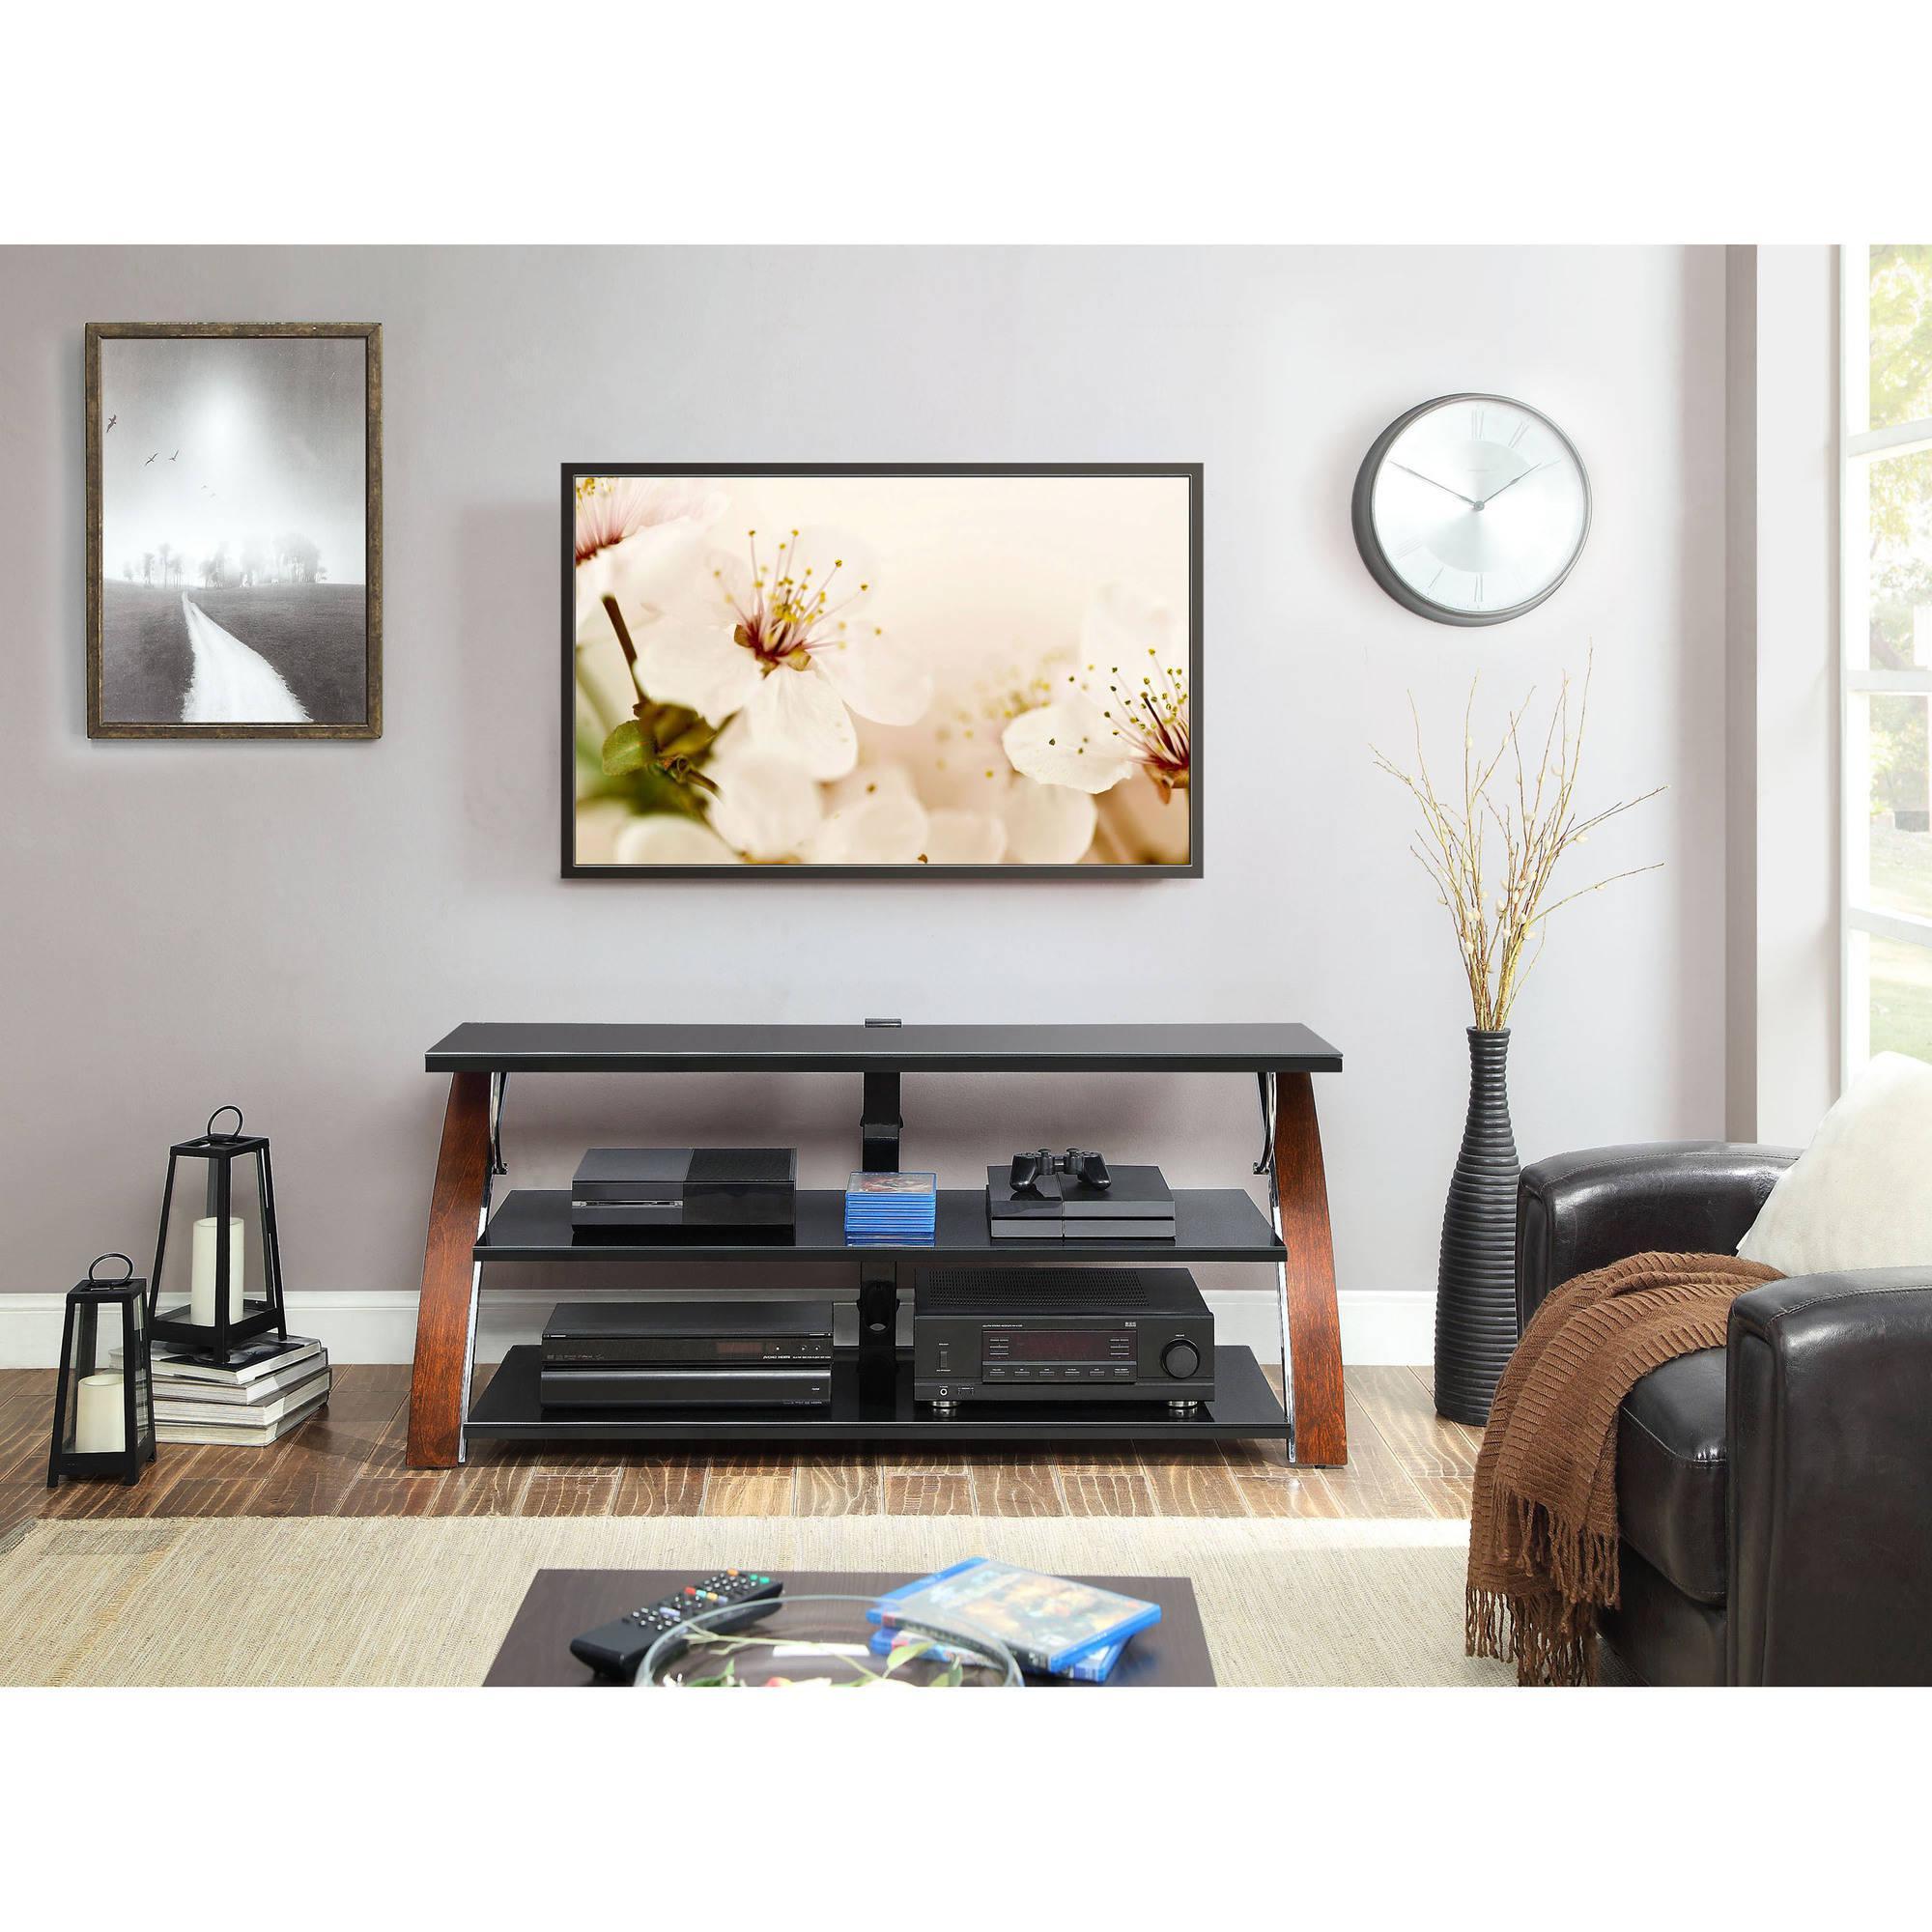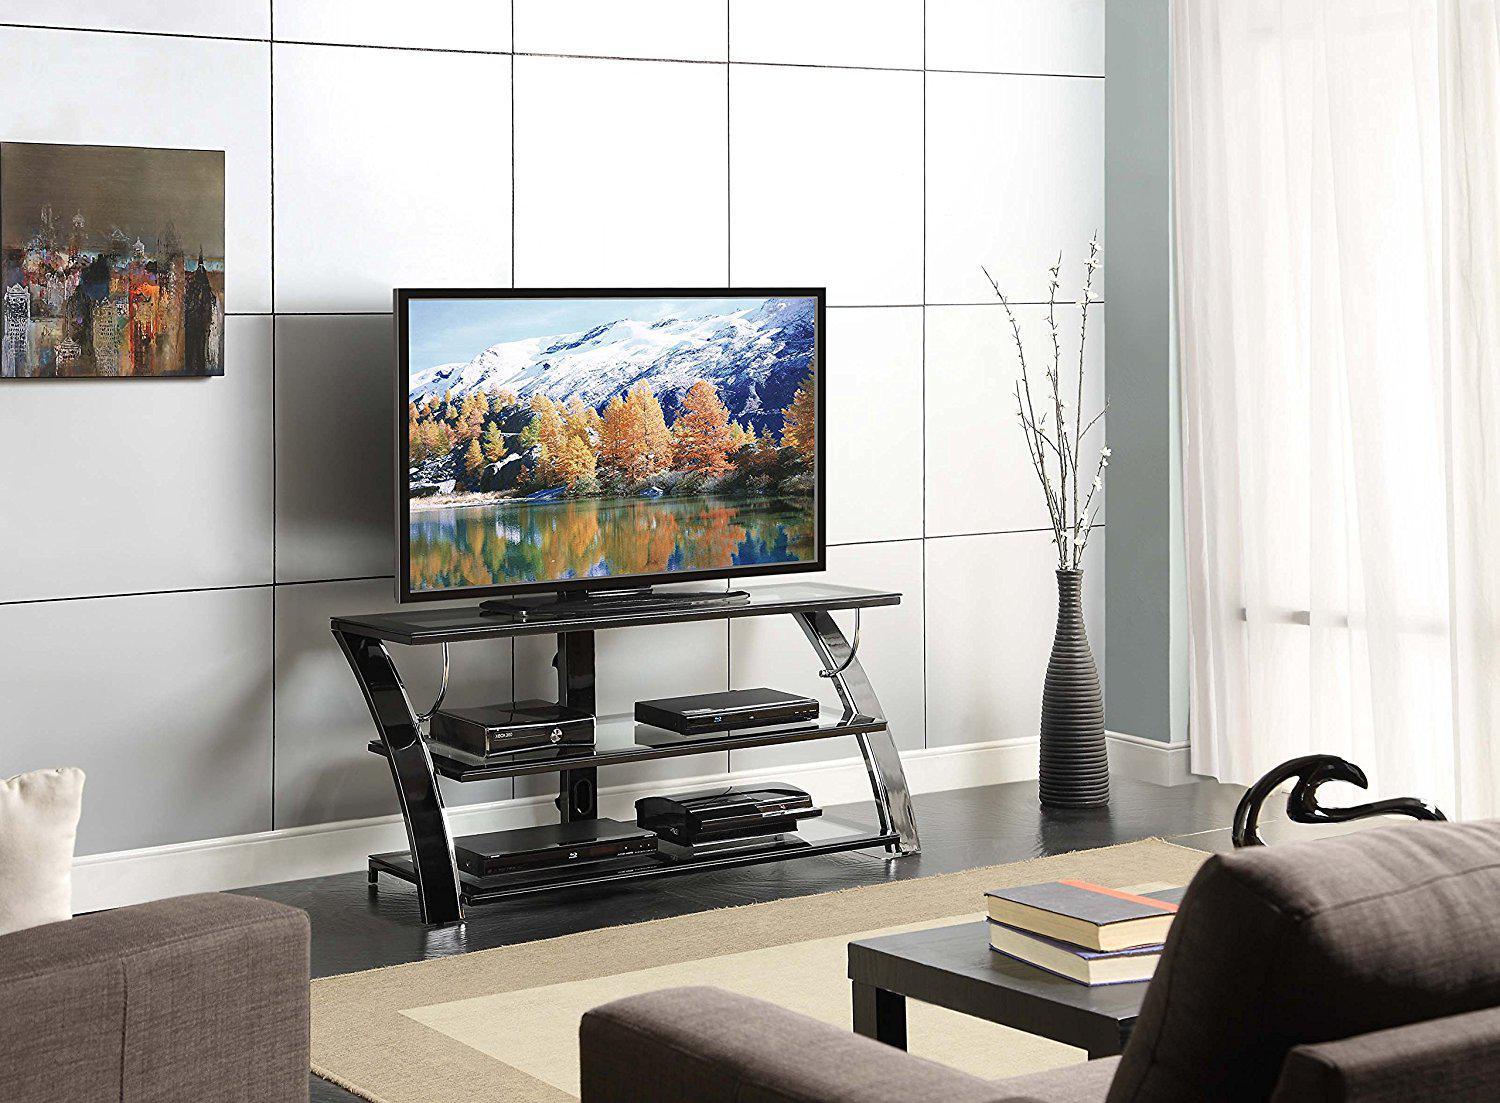The first image is the image on the left, the second image is the image on the right. For the images displayed, is the sentence "There is a dark brown wall behind the television in both images." factually correct? Answer yes or no. No. The first image is the image on the left, the second image is the image on the right. Analyze the images presented: Is the assertion "Left and right images each feature a TV stand with a curved piece on each end, but do not have the same picture playing on the TV." valid? Answer yes or no. Yes. 